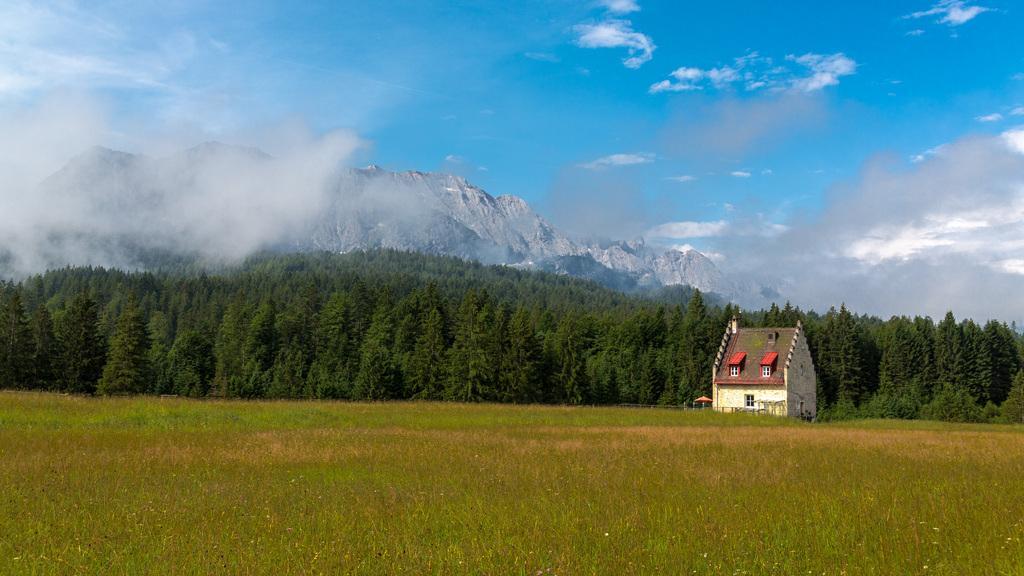Please provide a concise description of this image. At the bottom there are many plants. In the back there is a building with windows. Also there are trees, hills and sky with clouds. 